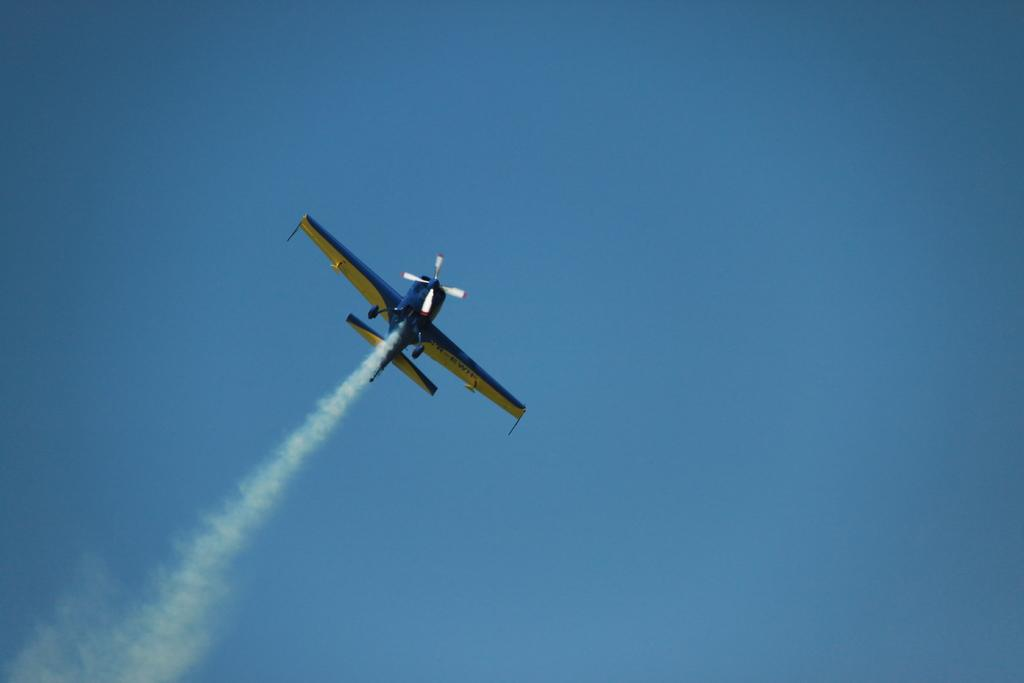What is the main subject of the image? The main subject of the image is an aeroplane. What is the aeroplane doing in the image? The aeroplane is flying in the air. What colors can be seen on the aeroplane? The aeroplane is in blue and yellow color. What is the color of the sky in the image? The sky is blue in the image. What type of game is being played by the aeroplane in the image? There is no game being played by the aeroplane in the image; it is simply flying in the air. Can you see any trucks in the image? There are no trucks present in the image; it only features an aeroplane flying in the air. 